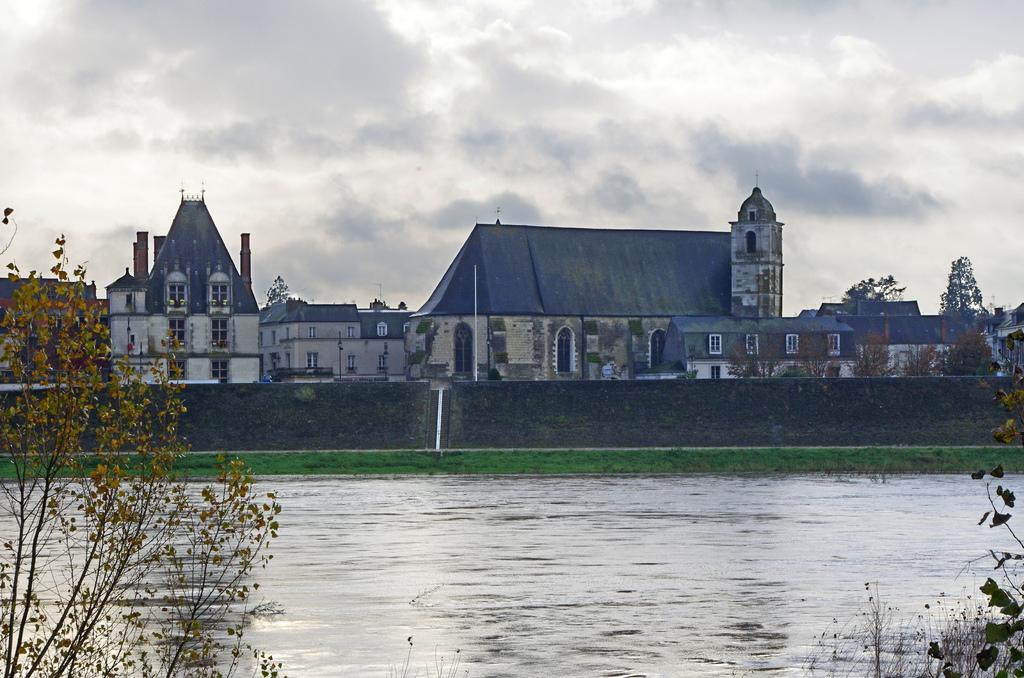What is visible in the image? There is water visible in the image. What can be seen in the background of the image? There are plants and buildings in the background of the image. How would you describe the color of the sky in the image? The sky is white and gray in color. What type of jewel can be seen falling from the sky in the image? There is no jewel falling from the sky in the image; the sky is white and gray in color. 